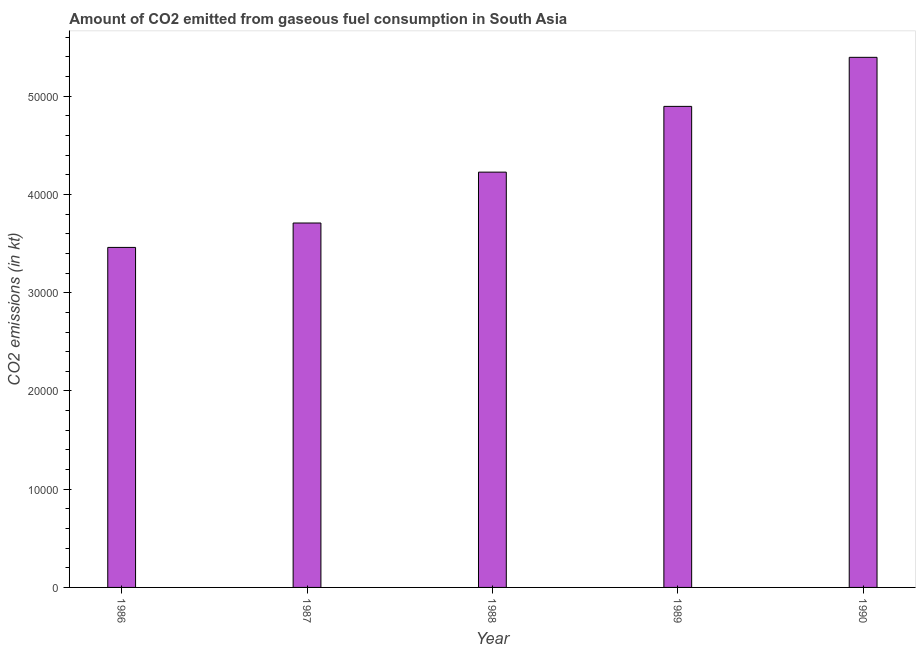Does the graph contain any zero values?
Keep it short and to the point. No. What is the title of the graph?
Offer a very short reply. Amount of CO2 emitted from gaseous fuel consumption in South Asia. What is the label or title of the X-axis?
Provide a short and direct response. Year. What is the label or title of the Y-axis?
Your answer should be compact. CO2 emissions (in kt). What is the co2 emissions from gaseous fuel consumption in 1986?
Provide a succinct answer. 3.46e+04. Across all years, what is the maximum co2 emissions from gaseous fuel consumption?
Give a very brief answer. 5.40e+04. Across all years, what is the minimum co2 emissions from gaseous fuel consumption?
Your answer should be compact. 3.46e+04. What is the sum of the co2 emissions from gaseous fuel consumption?
Offer a very short reply. 2.17e+05. What is the difference between the co2 emissions from gaseous fuel consumption in 1986 and 1988?
Your answer should be very brief. -7662.97. What is the average co2 emissions from gaseous fuel consumption per year?
Your response must be concise. 4.34e+04. What is the median co2 emissions from gaseous fuel consumption?
Give a very brief answer. 4.23e+04. In how many years, is the co2 emissions from gaseous fuel consumption greater than 46000 kt?
Give a very brief answer. 2. What is the ratio of the co2 emissions from gaseous fuel consumption in 1987 to that in 1990?
Your answer should be compact. 0.69. Is the difference between the co2 emissions from gaseous fuel consumption in 1986 and 1990 greater than the difference between any two years?
Provide a succinct answer. Yes. What is the difference between the highest and the second highest co2 emissions from gaseous fuel consumption?
Keep it short and to the point. 4992.48. What is the difference between the highest and the lowest co2 emissions from gaseous fuel consumption?
Keep it short and to the point. 1.93e+04. Are all the bars in the graph horizontal?
Provide a succinct answer. No. Are the values on the major ticks of Y-axis written in scientific E-notation?
Ensure brevity in your answer.  No. What is the CO2 emissions (in kt) in 1986?
Ensure brevity in your answer.  3.46e+04. What is the CO2 emissions (in kt) in 1987?
Your answer should be very brief. 3.71e+04. What is the CO2 emissions (in kt) in 1988?
Provide a succinct answer. 4.23e+04. What is the CO2 emissions (in kt) in 1989?
Make the answer very short. 4.90e+04. What is the CO2 emissions (in kt) in 1990?
Offer a terse response. 5.40e+04. What is the difference between the CO2 emissions (in kt) in 1986 and 1987?
Make the answer very short. -2484.88. What is the difference between the CO2 emissions (in kt) in 1986 and 1988?
Offer a terse response. -7662.97. What is the difference between the CO2 emissions (in kt) in 1986 and 1989?
Ensure brevity in your answer.  -1.44e+04. What is the difference between the CO2 emissions (in kt) in 1986 and 1990?
Your answer should be very brief. -1.93e+04. What is the difference between the CO2 emissions (in kt) in 1987 and 1988?
Ensure brevity in your answer.  -5178.09. What is the difference between the CO2 emissions (in kt) in 1987 and 1989?
Provide a succinct answer. -1.19e+04. What is the difference between the CO2 emissions (in kt) in 1987 and 1990?
Your answer should be compact. -1.69e+04. What is the difference between the CO2 emissions (in kt) in 1988 and 1989?
Your answer should be very brief. -6693.26. What is the difference between the CO2 emissions (in kt) in 1988 and 1990?
Offer a terse response. -1.17e+04. What is the difference between the CO2 emissions (in kt) in 1989 and 1990?
Keep it short and to the point. -4992.48. What is the ratio of the CO2 emissions (in kt) in 1986 to that in 1987?
Provide a succinct answer. 0.93. What is the ratio of the CO2 emissions (in kt) in 1986 to that in 1988?
Ensure brevity in your answer.  0.82. What is the ratio of the CO2 emissions (in kt) in 1986 to that in 1989?
Make the answer very short. 0.71. What is the ratio of the CO2 emissions (in kt) in 1986 to that in 1990?
Keep it short and to the point. 0.64. What is the ratio of the CO2 emissions (in kt) in 1987 to that in 1988?
Your answer should be compact. 0.88. What is the ratio of the CO2 emissions (in kt) in 1987 to that in 1989?
Ensure brevity in your answer.  0.76. What is the ratio of the CO2 emissions (in kt) in 1987 to that in 1990?
Provide a succinct answer. 0.69. What is the ratio of the CO2 emissions (in kt) in 1988 to that in 1989?
Provide a short and direct response. 0.86. What is the ratio of the CO2 emissions (in kt) in 1988 to that in 1990?
Provide a short and direct response. 0.78. What is the ratio of the CO2 emissions (in kt) in 1989 to that in 1990?
Your answer should be very brief. 0.91. 